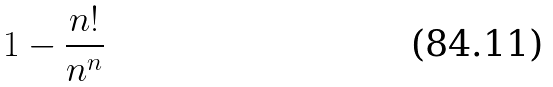Convert formula to latex. <formula><loc_0><loc_0><loc_500><loc_500>1 - \frac { n ! } { n ^ { n } }</formula> 